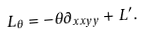<formula> <loc_0><loc_0><loc_500><loc_500>L _ { \theta } = - \theta \partial _ { x x y y } + L ^ { \prime } .</formula> 